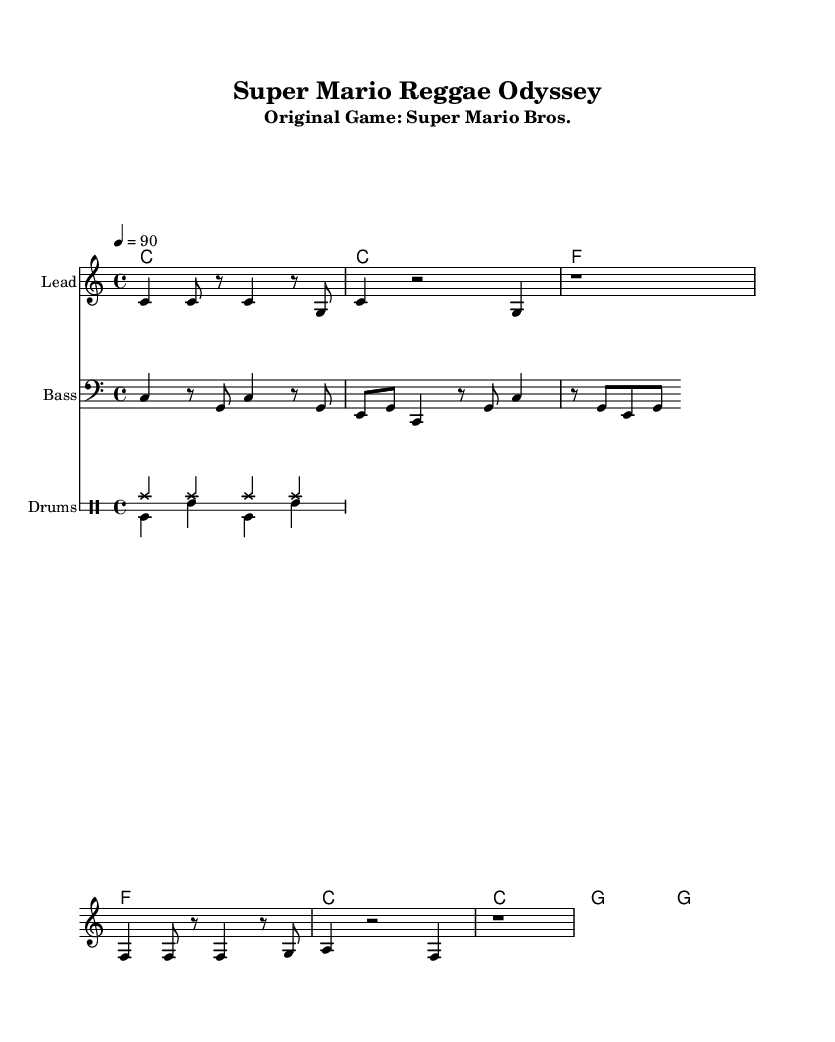What is the key signature of this music? The key signature is C major, which has no sharps or flats.
Answer: C major What is the time signature of the piece? The time signature appears at the beginning and indicates four beats per measure, represented as 4/4.
Answer: 4/4 What is the tempo marking for the song? The tempo marking is found near the beginning, indicating the speed of the music at 90 beats per minute, written as 4 = 90.
Answer: 90 How long is the first measure of the melody? The first measure is counted with four beats, consisting of two quarter notes and two eighth notes, which adds up to four beats total.
Answer: Four beats What is the style or genre of this cover? The sheet music indicates a reggae style due to its laid-back rhythms and use of offbeat accents, typical of reggae music.
Answer: Reggae How many chords are used in the chord progression? The chord progression consists of four different chords, repeating throughout the sections of the piece.
Answer: Four chords What humorous lyric is included in the song? The lyric includes a playful twist on the original Mario theme, with the phrase "It's-a me, Ras-ta Ma-ri-o," combining humor with the reggae style.
Answer: "It's-a me, Ras-ta Ma-ri-o." 